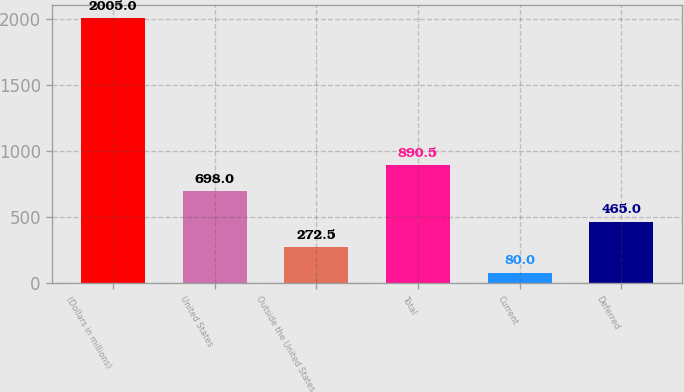<chart> <loc_0><loc_0><loc_500><loc_500><bar_chart><fcel>(Dollars in millions)<fcel>United States<fcel>Outside the United States<fcel>Total<fcel>Current<fcel>Deferred<nl><fcel>2005<fcel>698<fcel>272.5<fcel>890.5<fcel>80<fcel>465<nl></chart> 